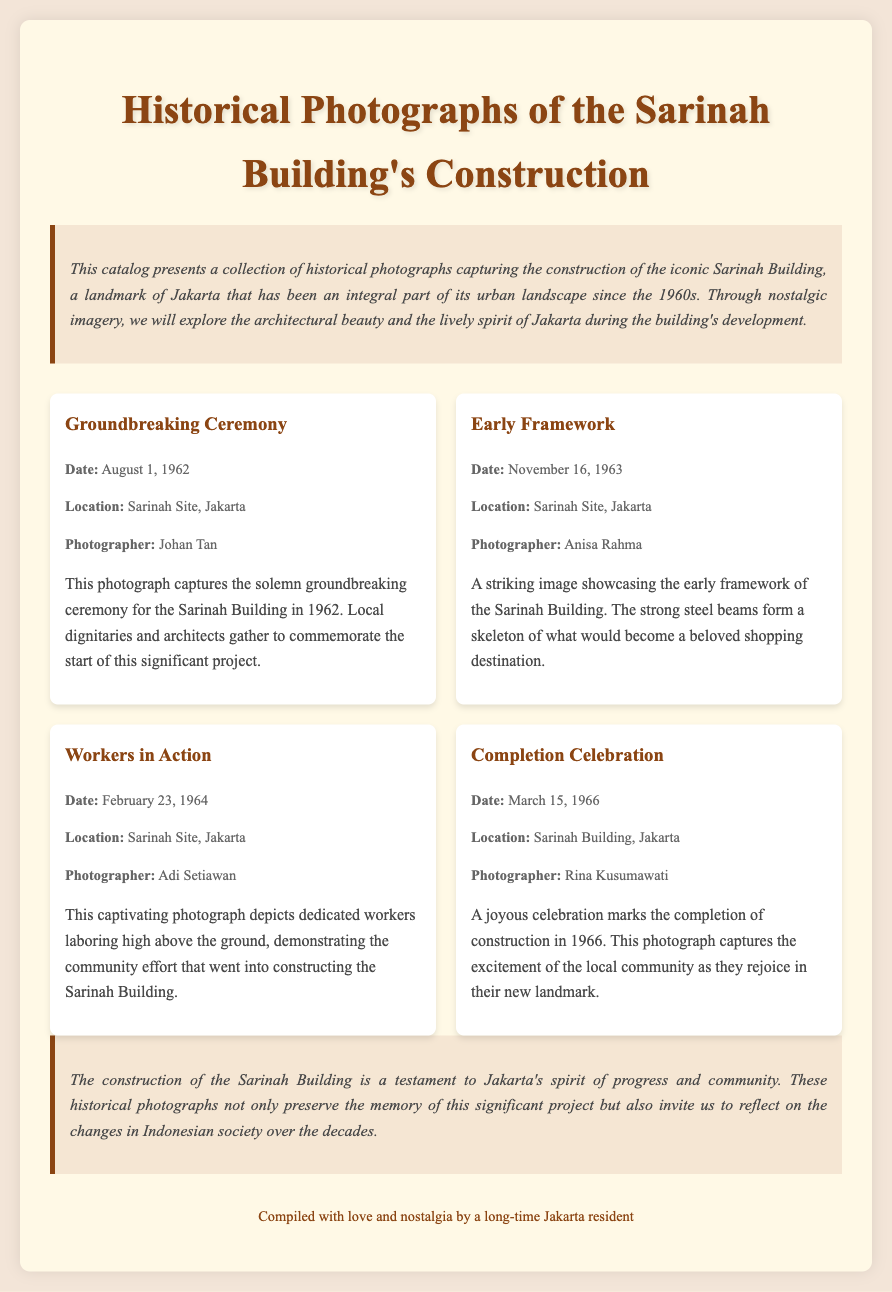What is the date of the groundbreaking ceremony? The date of the groundbreaking ceremony is explicitly mentioned in the document as August 1, 1962.
Answer: August 1, 1962 Who was the photographer for the completion celebration photograph? The document lists the name of the photographer for the completion celebration as Rina Kusumawati.
Answer: Rina Kusumawati What type of imagery is featured in the catalog? The document describes the imagery as captivating black-and-white imagery through the collection of historical photographs.
Answer: Black-and-white imagery When was the early framework photograph taken? The date for the early framework photograph is specifically noted in the document as November 16, 1963.
Answer: November 16, 1963 What event does the "Workers in Action" photograph depict? The context of the "Workers in Action" photograph in the document highlights dedicated workers laboring during the construction process.
Answer: Laboring during construction What is the significance of the Sarinah Building according to the conclusion? The conclusion emphasizes that the Sarinah Building represents Jakarta's spirit of progress and community.
Answer: Progress and community Who gathered for the groundbreaking ceremony? The document mentions that local dignitaries and architects gathered for the solemn groundbreaking ceremony.
Answer: Local dignitaries and architects What does the conclusion invite us to reflect on? The conclusion invites reflection on the changes in Indonesian society over the decades since the building's construction.
Answer: Changes in Indonesian society 